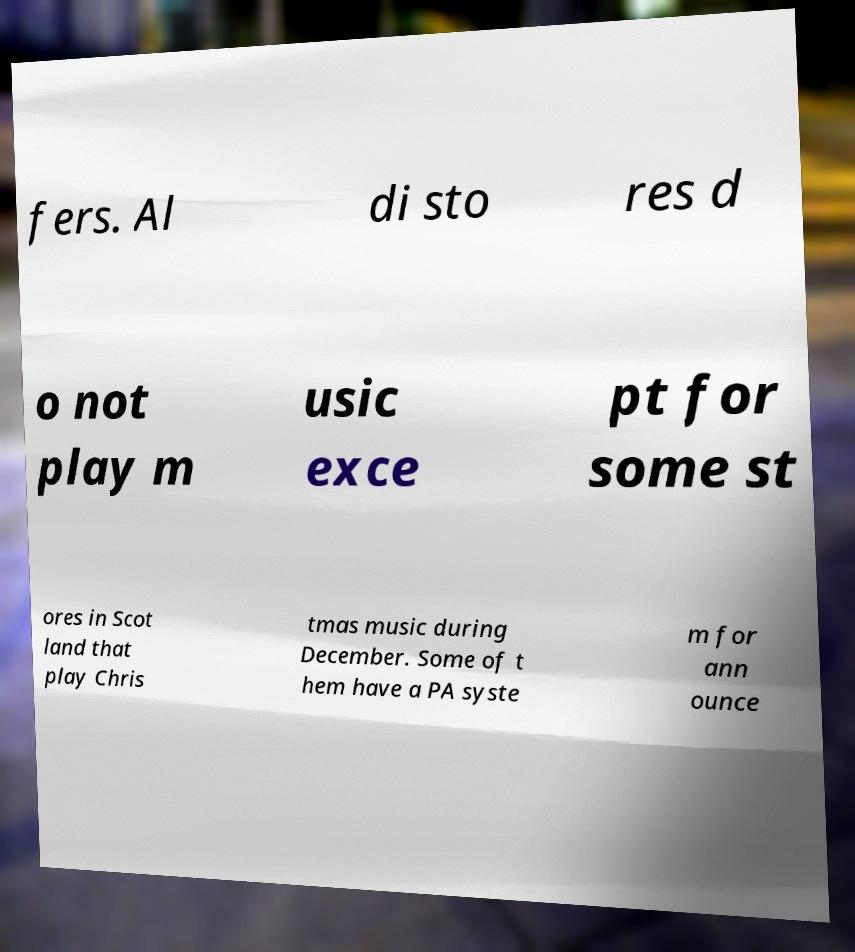Please read and relay the text visible in this image. What does it say? fers. Al di sto res d o not play m usic exce pt for some st ores in Scot land that play Chris tmas music during December. Some of t hem have a PA syste m for ann ounce 